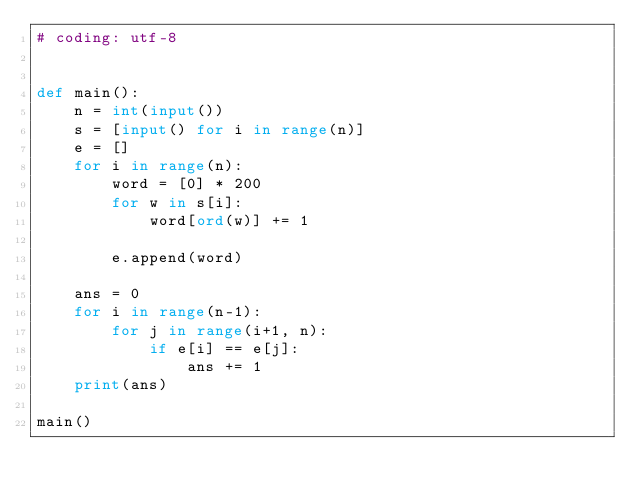Convert code to text. <code><loc_0><loc_0><loc_500><loc_500><_Python_># coding: utf-8


def main():
    n = int(input())
    s = [input() for i in range(n)]
    e = []
    for i in range(n):
        word = [0] * 200
        for w in s[i]:
            word[ord(w)] += 1

        e.append(word)

    ans = 0
    for i in range(n-1):
        for j in range(i+1, n):
            if e[i] == e[j]:
                ans += 1
    print(ans)

main()
</code> 